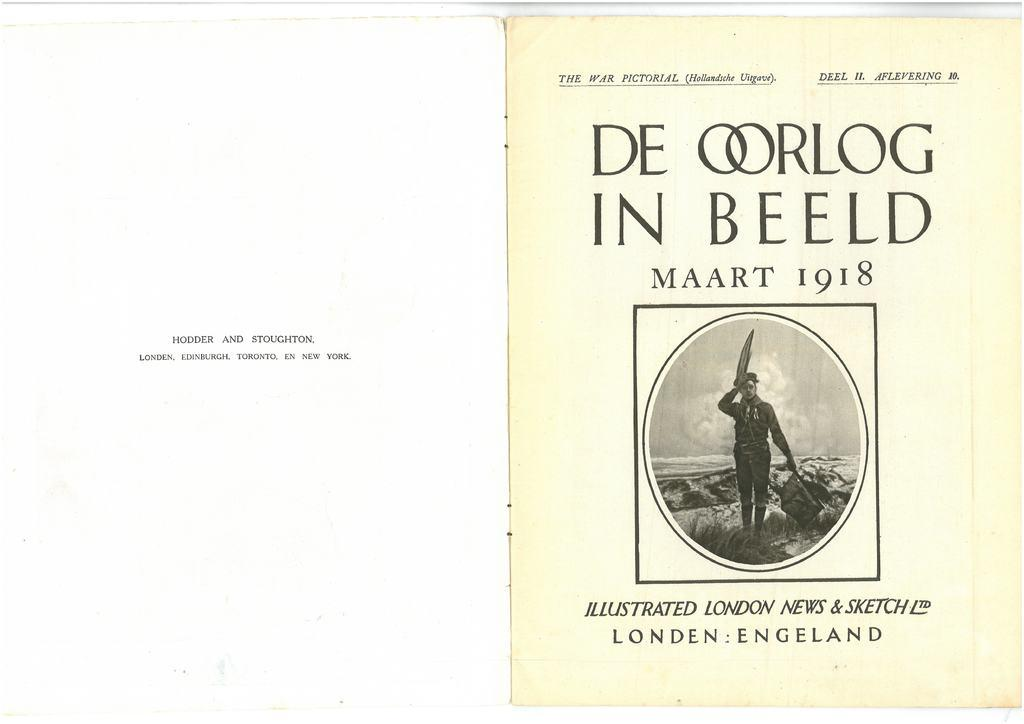<image>
Relay a brief, clear account of the picture shown. The War Pictorial De Oorlog in Beeld is dated 1918 